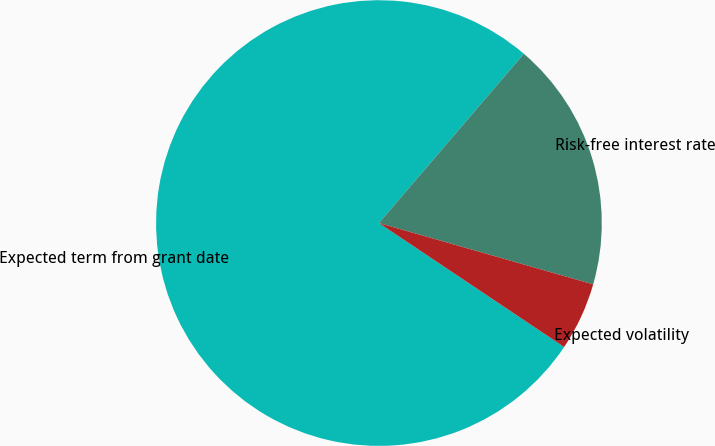Convert chart. <chart><loc_0><loc_0><loc_500><loc_500><pie_chart><fcel>Expected term from grant date<fcel>Risk-free interest rate<fcel>Expected volatility<nl><fcel>76.88%<fcel>18.17%<fcel>4.95%<nl></chart> 